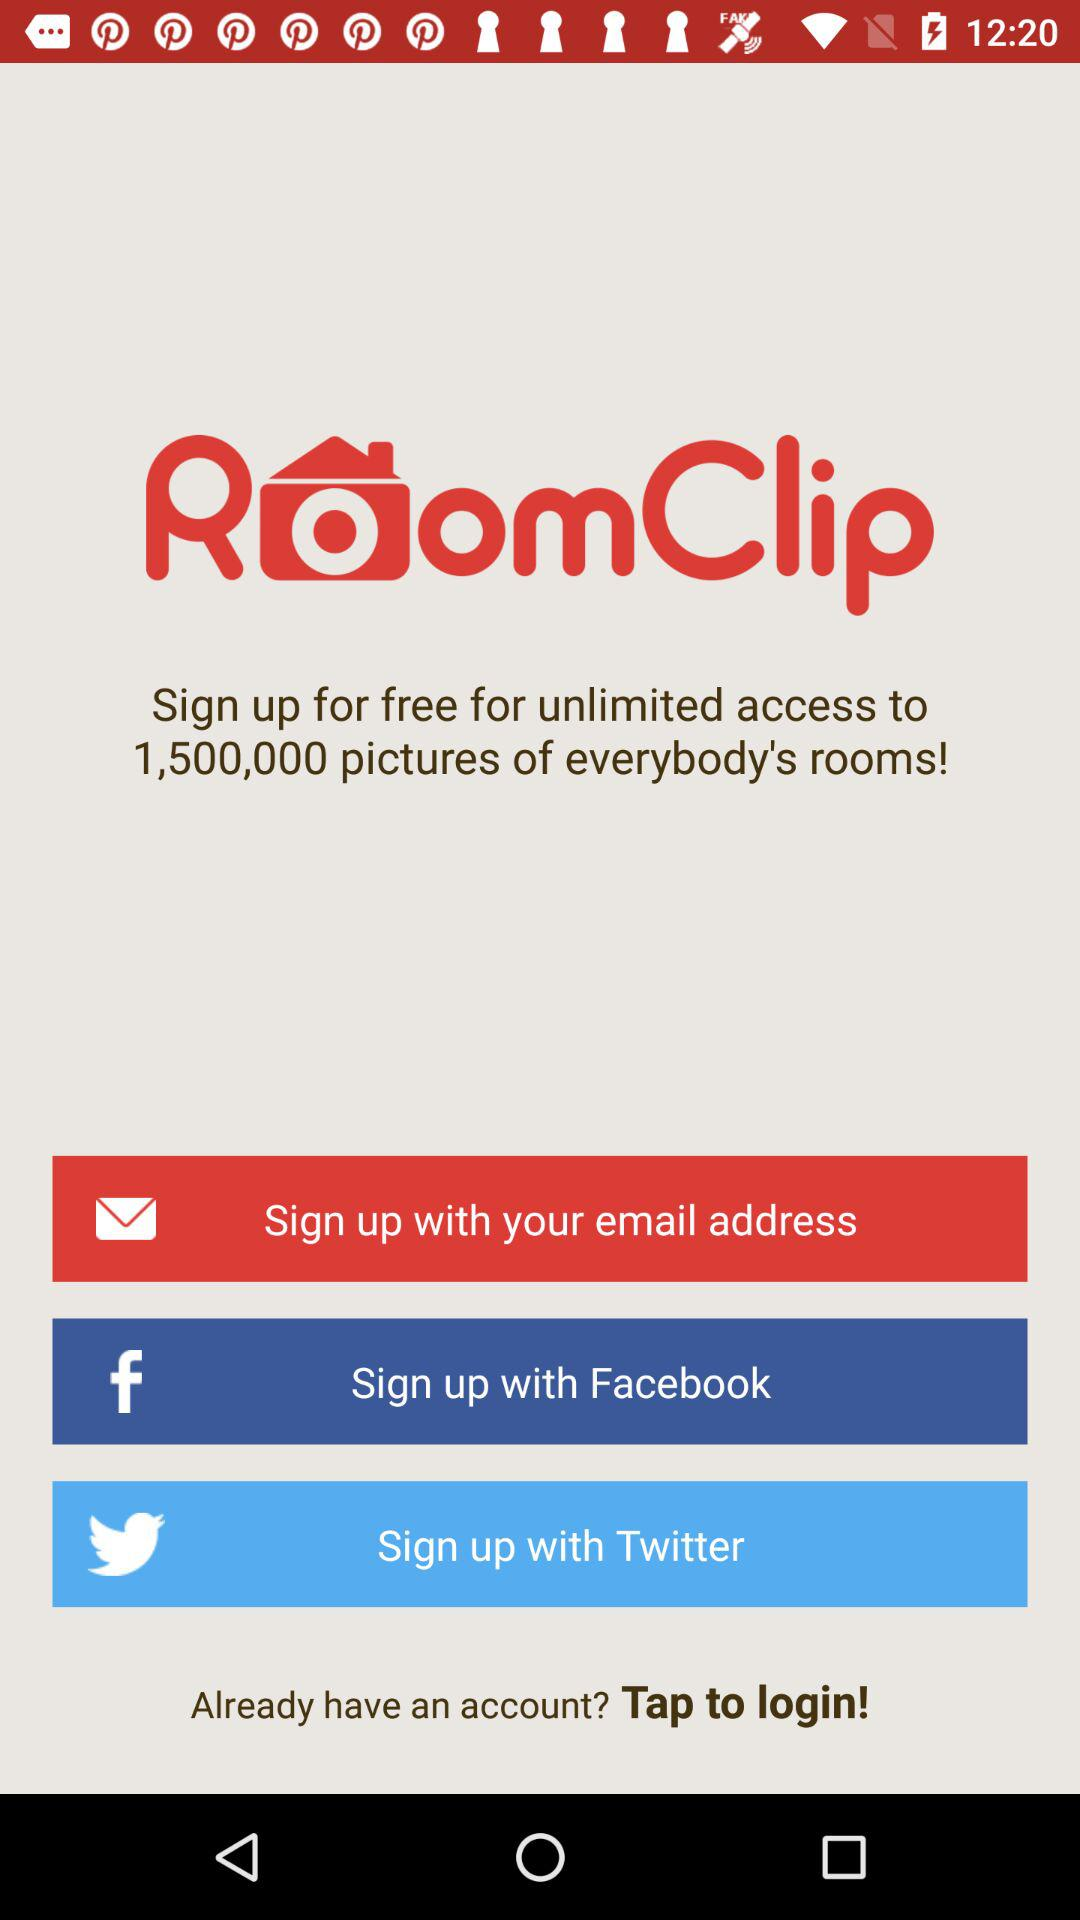What do we need to do for free unlimited access to 1,500,000 pictures of everybody's rooms? You need to sign up for free unlimited access to 1,500,000 pictures of everybody's rooms. 